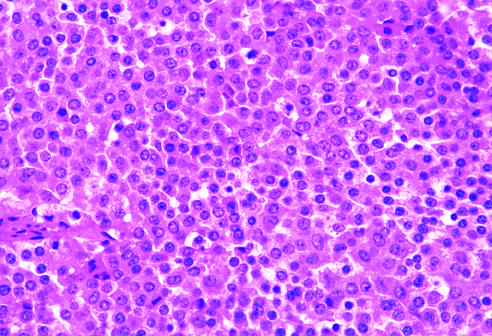what does the monomorphism of these cells contrast with?
Answer the question using a single word or phrase. The admixture of cells seen in the normal anterior pituitary gland 